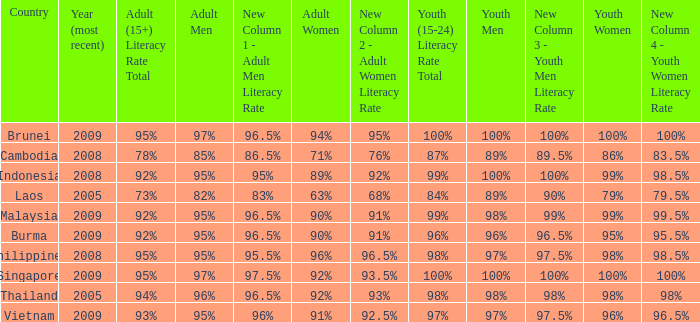Which country has a Youth (15-24) Literacy Rate Total of 100% and has an Adult Women Literacy rate of 92%? Singapore. 